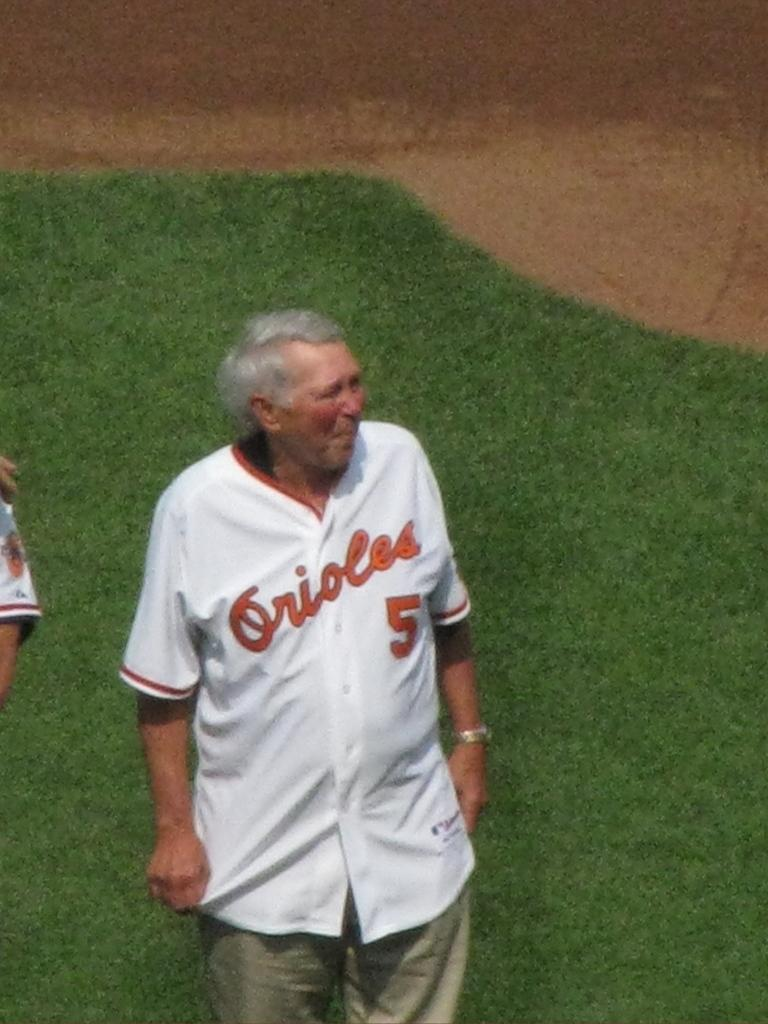<image>
Create a compact narrative representing the image presented. An old man wearing an Orioles jersey stands in a baseball field. 